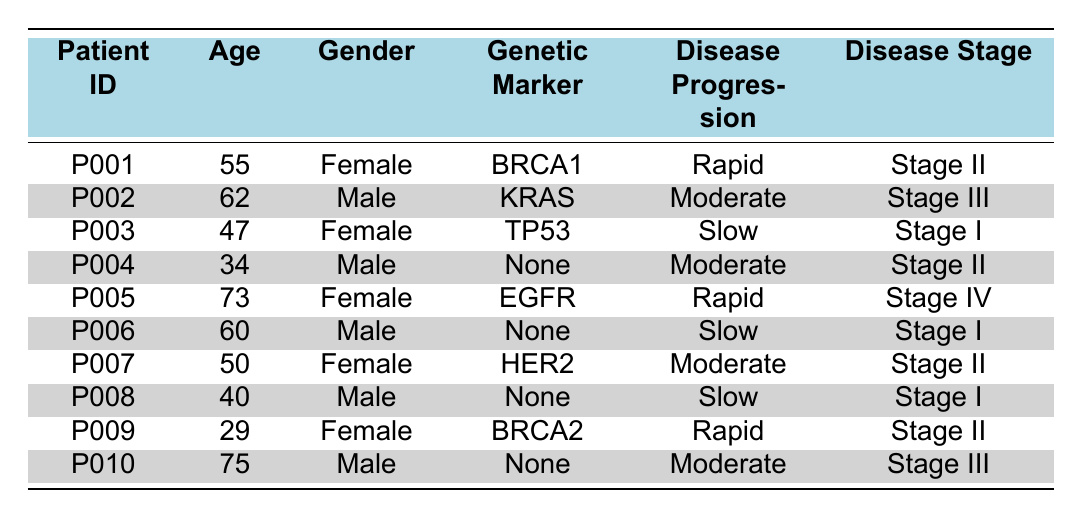What is the disease progression rate for patient P005? Looking at the table, I locate the row for patient P005 and see the column labeled "Disease Progression." This shows that the progression rate for patient P005 is "Rapid."
Answer: Rapid How many patients have a "Slow" disease progression rate? I scan through the table and count the patients classified as having a "Slow" progression rate. The patients are P003, P006, and P008. That's a total of 3 patients.
Answer: 3 Is it true that all patients with the genetic marker "None" have a moderate disease progression rate? I review the entries for patients with the genetic marker "None," which are P004, P006, P008, and P010. Among these, P004 and P010 have a moderate progression rate, while P006 and P008 have a slow progression rate. Therefore, the statement is false.
Answer: No What is the average age of patients who have a rapid disease progression rate? The patients with rapid disease progression are P001 (55), P005 (73), and P009 (29). I add their ages: 55 + 73 + 29 = 157. There are 3 patients, so the average age is 157 / 3 = 52.33.
Answer: 52.33 How many female patients are there in the dataset? I count the female patients by locating the gender column and tallying the entries. The female patients in the table are P001, P003, P005, P007, and P009. This gives me a total of 5 female patients.
Answer: 5 What is the disease stage at diagnosis for patient P010? To answer this, I locate patient P010 in the table. The column labeled "Disease Stage" indicates that it is "Stage III."
Answer: Stage III Which age group has the highest disease progression rate and what is that rate? I check the entries for the disease progression rates in conjunction with the ages of patients. The patients with a rapid disease progression are aged 55 (P001), 73 (P005), and 29 (P009). The highest rate in the dataset is "Rapid." Therefore, there isn't a specific age group; rather, the highest rate is linked to multiple ages.
Answer: Rapid How many patients diagnosed at Stage II show a moderate disease progression rate? I examine the table to find patients diagnosed at Stage II and check their progression rates. The relevant patients are P001 (Rapid), P004 (Moderate), and P007 (Moderate). The count of those with a moderate progression rate is 2.
Answer: 2 